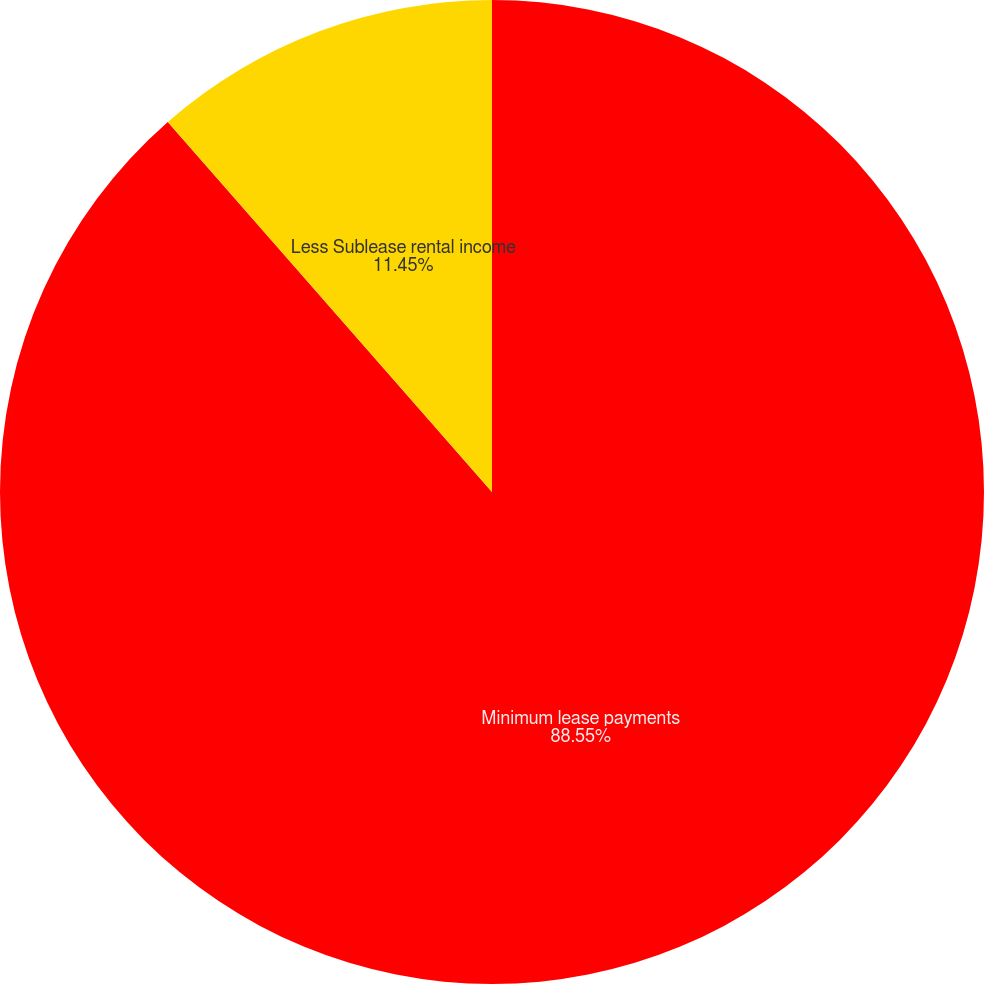<chart> <loc_0><loc_0><loc_500><loc_500><pie_chart><fcel>Minimum lease payments<fcel>Less Sublease rental income<nl><fcel>88.55%<fcel>11.45%<nl></chart> 